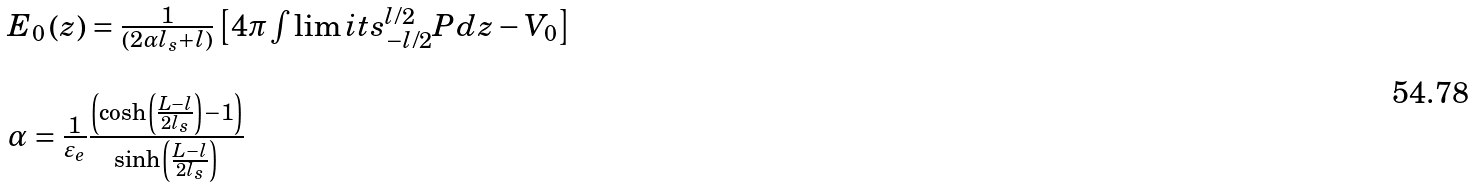Convert formula to latex. <formula><loc_0><loc_0><loc_500><loc_500>\begin{array} { l } E _ { 0 } \left ( z \right ) = \frac { 1 } { { \left ( { 2 \alpha l _ { s } + l } \right ) } } \left [ { 4 \pi \int \lim i t s _ { - l / 2 } ^ { l / 2 } { P d z } - V _ { 0 } } \right ] \\ \\ \alpha = \frac { 1 } { \varepsilon _ { e } } \frac { { \left ( { \cosh \left ( { \frac { L - l } { 2 l _ { s } } } \right ) - 1 } \right ) } } { { \sinh \left ( { \frac { L - l } { 2 l _ { s } } } \right ) } } \\ \end{array}</formula> 